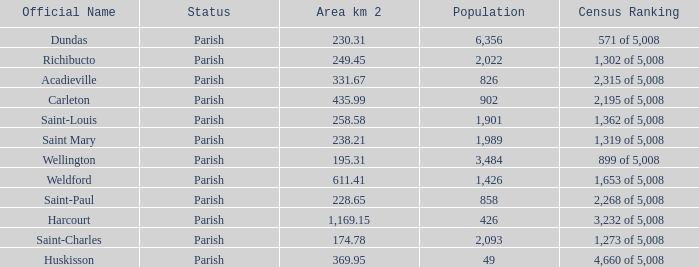For Saint-Paul parish, if it has an area of over 228.65 kilometers how many people live there? 0.0. 